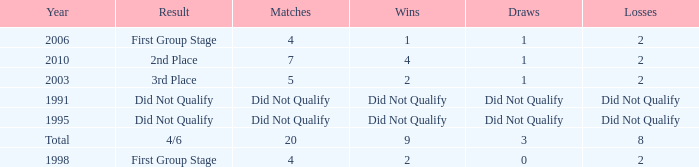How many draws were there in 2006? 1.0. 